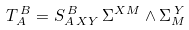Convert formula to latex. <formula><loc_0><loc_0><loc_500><loc_500>T _ { A } ^ { \, B } = S _ { A \, X Y } ^ { \, B } \, \Sigma ^ { X M } \wedge \Sigma _ { M } ^ { \, Y }</formula> 